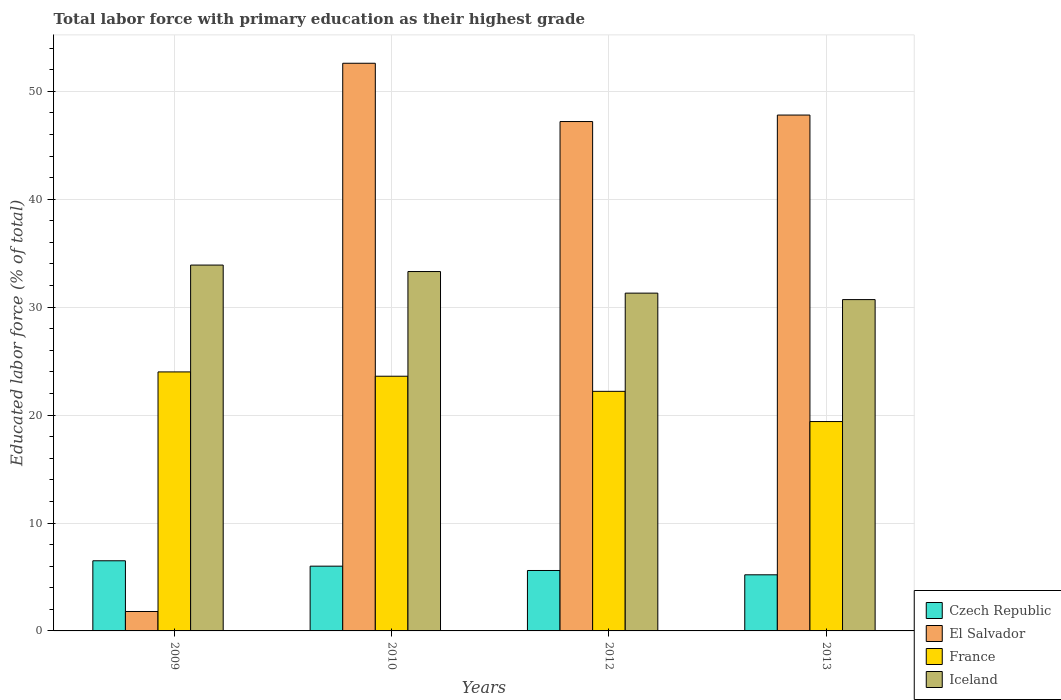Are the number of bars per tick equal to the number of legend labels?
Your response must be concise. Yes. How many bars are there on the 3rd tick from the right?
Your response must be concise. 4. In how many cases, is the number of bars for a given year not equal to the number of legend labels?
Offer a terse response. 0. What is the percentage of total labor force with primary education in France in 2012?
Your answer should be compact. 22.2. Across all years, what is the minimum percentage of total labor force with primary education in El Salvador?
Your answer should be compact. 1.8. In which year was the percentage of total labor force with primary education in Iceland maximum?
Ensure brevity in your answer.  2009. In which year was the percentage of total labor force with primary education in Czech Republic minimum?
Make the answer very short. 2013. What is the total percentage of total labor force with primary education in El Salvador in the graph?
Make the answer very short. 149.4. What is the difference between the percentage of total labor force with primary education in France in 2012 and that in 2013?
Ensure brevity in your answer.  2.8. What is the average percentage of total labor force with primary education in Iceland per year?
Provide a succinct answer. 32.3. In the year 2013, what is the difference between the percentage of total labor force with primary education in El Salvador and percentage of total labor force with primary education in France?
Provide a succinct answer. 28.4. In how many years, is the percentage of total labor force with primary education in El Salvador greater than 10 %?
Your answer should be very brief. 3. What is the ratio of the percentage of total labor force with primary education in Iceland in 2009 to that in 2010?
Offer a very short reply. 1.02. Is the percentage of total labor force with primary education in El Salvador in 2009 less than that in 2013?
Your response must be concise. Yes. Is the difference between the percentage of total labor force with primary education in El Salvador in 2010 and 2013 greater than the difference between the percentage of total labor force with primary education in France in 2010 and 2013?
Make the answer very short. Yes. What is the difference between the highest and the second highest percentage of total labor force with primary education in Iceland?
Your answer should be very brief. 0.6. What is the difference between the highest and the lowest percentage of total labor force with primary education in France?
Provide a succinct answer. 4.6. In how many years, is the percentage of total labor force with primary education in El Salvador greater than the average percentage of total labor force with primary education in El Salvador taken over all years?
Your answer should be very brief. 3. Is it the case that in every year, the sum of the percentage of total labor force with primary education in Czech Republic and percentage of total labor force with primary education in France is greater than the sum of percentage of total labor force with primary education in El Salvador and percentage of total labor force with primary education in Iceland?
Provide a succinct answer. No. What does the 1st bar from the left in 2010 represents?
Your answer should be very brief. Czech Republic. What does the 1st bar from the right in 2012 represents?
Keep it short and to the point. Iceland. How many bars are there?
Keep it short and to the point. 16. How many years are there in the graph?
Your answer should be very brief. 4. Are the values on the major ticks of Y-axis written in scientific E-notation?
Your answer should be very brief. No. Does the graph contain any zero values?
Offer a very short reply. No. Does the graph contain grids?
Provide a succinct answer. Yes. Where does the legend appear in the graph?
Provide a short and direct response. Bottom right. How are the legend labels stacked?
Your answer should be very brief. Vertical. What is the title of the graph?
Keep it short and to the point. Total labor force with primary education as their highest grade. Does "Dominica" appear as one of the legend labels in the graph?
Provide a short and direct response. No. What is the label or title of the X-axis?
Offer a very short reply. Years. What is the label or title of the Y-axis?
Your answer should be very brief. Educated labor force (% of total). What is the Educated labor force (% of total) in El Salvador in 2009?
Ensure brevity in your answer.  1.8. What is the Educated labor force (% of total) in France in 2009?
Offer a very short reply. 24. What is the Educated labor force (% of total) in Iceland in 2009?
Provide a succinct answer. 33.9. What is the Educated labor force (% of total) of Czech Republic in 2010?
Offer a terse response. 6. What is the Educated labor force (% of total) in El Salvador in 2010?
Your answer should be compact. 52.6. What is the Educated labor force (% of total) in France in 2010?
Your answer should be compact. 23.6. What is the Educated labor force (% of total) in Iceland in 2010?
Offer a terse response. 33.3. What is the Educated labor force (% of total) of Czech Republic in 2012?
Make the answer very short. 5.6. What is the Educated labor force (% of total) of El Salvador in 2012?
Offer a terse response. 47.2. What is the Educated labor force (% of total) of France in 2012?
Your response must be concise. 22.2. What is the Educated labor force (% of total) of Iceland in 2012?
Keep it short and to the point. 31.3. What is the Educated labor force (% of total) in Czech Republic in 2013?
Ensure brevity in your answer.  5.2. What is the Educated labor force (% of total) of El Salvador in 2013?
Offer a very short reply. 47.8. What is the Educated labor force (% of total) of France in 2013?
Offer a terse response. 19.4. What is the Educated labor force (% of total) in Iceland in 2013?
Make the answer very short. 30.7. Across all years, what is the maximum Educated labor force (% of total) of Czech Republic?
Your answer should be very brief. 6.5. Across all years, what is the maximum Educated labor force (% of total) of El Salvador?
Provide a succinct answer. 52.6. Across all years, what is the maximum Educated labor force (% of total) in Iceland?
Your response must be concise. 33.9. Across all years, what is the minimum Educated labor force (% of total) in Czech Republic?
Your answer should be compact. 5.2. Across all years, what is the minimum Educated labor force (% of total) of El Salvador?
Your response must be concise. 1.8. Across all years, what is the minimum Educated labor force (% of total) of France?
Provide a succinct answer. 19.4. Across all years, what is the minimum Educated labor force (% of total) in Iceland?
Provide a short and direct response. 30.7. What is the total Educated labor force (% of total) in Czech Republic in the graph?
Offer a very short reply. 23.3. What is the total Educated labor force (% of total) in El Salvador in the graph?
Ensure brevity in your answer.  149.4. What is the total Educated labor force (% of total) of France in the graph?
Your answer should be compact. 89.2. What is the total Educated labor force (% of total) in Iceland in the graph?
Offer a terse response. 129.2. What is the difference between the Educated labor force (% of total) in El Salvador in 2009 and that in 2010?
Your answer should be compact. -50.8. What is the difference between the Educated labor force (% of total) in Czech Republic in 2009 and that in 2012?
Your answer should be compact. 0.9. What is the difference between the Educated labor force (% of total) in El Salvador in 2009 and that in 2012?
Your answer should be compact. -45.4. What is the difference between the Educated labor force (% of total) of France in 2009 and that in 2012?
Provide a succinct answer. 1.8. What is the difference between the Educated labor force (% of total) in Iceland in 2009 and that in 2012?
Your answer should be compact. 2.6. What is the difference between the Educated labor force (% of total) in El Salvador in 2009 and that in 2013?
Offer a terse response. -46. What is the difference between the Educated labor force (% of total) in Iceland in 2009 and that in 2013?
Offer a very short reply. 3.2. What is the difference between the Educated labor force (% of total) of Iceland in 2010 and that in 2012?
Your answer should be compact. 2. What is the difference between the Educated labor force (% of total) of Czech Republic in 2010 and that in 2013?
Ensure brevity in your answer.  0.8. What is the difference between the Educated labor force (% of total) in Iceland in 2010 and that in 2013?
Provide a short and direct response. 2.6. What is the difference between the Educated labor force (% of total) of Iceland in 2012 and that in 2013?
Offer a terse response. 0.6. What is the difference between the Educated labor force (% of total) in Czech Republic in 2009 and the Educated labor force (% of total) in El Salvador in 2010?
Make the answer very short. -46.1. What is the difference between the Educated labor force (% of total) in Czech Republic in 2009 and the Educated labor force (% of total) in France in 2010?
Your answer should be very brief. -17.1. What is the difference between the Educated labor force (% of total) of Czech Republic in 2009 and the Educated labor force (% of total) of Iceland in 2010?
Provide a succinct answer. -26.8. What is the difference between the Educated labor force (% of total) of El Salvador in 2009 and the Educated labor force (% of total) of France in 2010?
Your response must be concise. -21.8. What is the difference between the Educated labor force (% of total) of El Salvador in 2009 and the Educated labor force (% of total) of Iceland in 2010?
Your response must be concise. -31.5. What is the difference between the Educated labor force (% of total) of Czech Republic in 2009 and the Educated labor force (% of total) of El Salvador in 2012?
Your response must be concise. -40.7. What is the difference between the Educated labor force (% of total) of Czech Republic in 2009 and the Educated labor force (% of total) of France in 2012?
Make the answer very short. -15.7. What is the difference between the Educated labor force (% of total) in Czech Republic in 2009 and the Educated labor force (% of total) in Iceland in 2012?
Provide a short and direct response. -24.8. What is the difference between the Educated labor force (% of total) in El Salvador in 2009 and the Educated labor force (% of total) in France in 2012?
Provide a short and direct response. -20.4. What is the difference between the Educated labor force (% of total) of El Salvador in 2009 and the Educated labor force (% of total) of Iceland in 2012?
Your answer should be very brief. -29.5. What is the difference between the Educated labor force (% of total) of France in 2009 and the Educated labor force (% of total) of Iceland in 2012?
Ensure brevity in your answer.  -7.3. What is the difference between the Educated labor force (% of total) in Czech Republic in 2009 and the Educated labor force (% of total) in El Salvador in 2013?
Provide a succinct answer. -41.3. What is the difference between the Educated labor force (% of total) in Czech Republic in 2009 and the Educated labor force (% of total) in Iceland in 2013?
Ensure brevity in your answer.  -24.2. What is the difference between the Educated labor force (% of total) of El Salvador in 2009 and the Educated labor force (% of total) of France in 2013?
Make the answer very short. -17.6. What is the difference between the Educated labor force (% of total) in El Salvador in 2009 and the Educated labor force (% of total) in Iceland in 2013?
Your answer should be compact. -28.9. What is the difference between the Educated labor force (% of total) in Czech Republic in 2010 and the Educated labor force (% of total) in El Salvador in 2012?
Give a very brief answer. -41.2. What is the difference between the Educated labor force (% of total) in Czech Republic in 2010 and the Educated labor force (% of total) in France in 2012?
Your answer should be very brief. -16.2. What is the difference between the Educated labor force (% of total) of Czech Republic in 2010 and the Educated labor force (% of total) of Iceland in 2012?
Give a very brief answer. -25.3. What is the difference between the Educated labor force (% of total) in El Salvador in 2010 and the Educated labor force (% of total) in France in 2012?
Your response must be concise. 30.4. What is the difference between the Educated labor force (% of total) in El Salvador in 2010 and the Educated labor force (% of total) in Iceland in 2012?
Your response must be concise. 21.3. What is the difference between the Educated labor force (% of total) in France in 2010 and the Educated labor force (% of total) in Iceland in 2012?
Keep it short and to the point. -7.7. What is the difference between the Educated labor force (% of total) in Czech Republic in 2010 and the Educated labor force (% of total) in El Salvador in 2013?
Your answer should be very brief. -41.8. What is the difference between the Educated labor force (% of total) in Czech Republic in 2010 and the Educated labor force (% of total) in France in 2013?
Your answer should be very brief. -13.4. What is the difference between the Educated labor force (% of total) in Czech Republic in 2010 and the Educated labor force (% of total) in Iceland in 2013?
Make the answer very short. -24.7. What is the difference between the Educated labor force (% of total) of El Salvador in 2010 and the Educated labor force (% of total) of France in 2013?
Your answer should be compact. 33.2. What is the difference between the Educated labor force (% of total) in El Salvador in 2010 and the Educated labor force (% of total) in Iceland in 2013?
Make the answer very short. 21.9. What is the difference between the Educated labor force (% of total) of France in 2010 and the Educated labor force (% of total) of Iceland in 2013?
Offer a terse response. -7.1. What is the difference between the Educated labor force (% of total) in Czech Republic in 2012 and the Educated labor force (% of total) in El Salvador in 2013?
Ensure brevity in your answer.  -42.2. What is the difference between the Educated labor force (% of total) of Czech Republic in 2012 and the Educated labor force (% of total) of France in 2013?
Keep it short and to the point. -13.8. What is the difference between the Educated labor force (% of total) in Czech Republic in 2012 and the Educated labor force (% of total) in Iceland in 2013?
Offer a very short reply. -25.1. What is the difference between the Educated labor force (% of total) of El Salvador in 2012 and the Educated labor force (% of total) of France in 2013?
Keep it short and to the point. 27.8. What is the average Educated labor force (% of total) in Czech Republic per year?
Offer a very short reply. 5.83. What is the average Educated labor force (% of total) of El Salvador per year?
Your response must be concise. 37.35. What is the average Educated labor force (% of total) of France per year?
Give a very brief answer. 22.3. What is the average Educated labor force (% of total) of Iceland per year?
Provide a succinct answer. 32.3. In the year 2009, what is the difference between the Educated labor force (% of total) of Czech Republic and Educated labor force (% of total) of El Salvador?
Your answer should be very brief. 4.7. In the year 2009, what is the difference between the Educated labor force (% of total) of Czech Republic and Educated labor force (% of total) of France?
Ensure brevity in your answer.  -17.5. In the year 2009, what is the difference between the Educated labor force (% of total) in Czech Republic and Educated labor force (% of total) in Iceland?
Keep it short and to the point. -27.4. In the year 2009, what is the difference between the Educated labor force (% of total) of El Salvador and Educated labor force (% of total) of France?
Give a very brief answer. -22.2. In the year 2009, what is the difference between the Educated labor force (% of total) in El Salvador and Educated labor force (% of total) in Iceland?
Offer a terse response. -32.1. In the year 2009, what is the difference between the Educated labor force (% of total) in France and Educated labor force (% of total) in Iceland?
Give a very brief answer. -9.9. In the year 2010, what is the difference between the Educated labor force (% of total) of Czech Republic and Educated labor force (% of total) of El Salvador?
Ensure brevity in your answer.  -46.6. In the year 2010, what is the difference between the Educated labor force (% of total) in Czech Republic and Educated labor force (% of total) in France?
Your answer should be compact. -17.6. In the year 2010, what is the difference between the Educated labor force (% of total) of Czech Republic and Educated labor force (% of total) of Iceland?
Offer a very short reply. -27.3. In the year 2010, what is the difference between the Educated labor force (% of total) of El Salvador and Educated labor force (% of total) of France?
Give a very brief answer. 29. In the year 2010, what is the difference between the Educated labor force (% of total) of El Salvador and Educated labor force (% of total) of Iceland?
Give a very brief answer. 19.3. In the year 2010, what is the difference between the Educated labor force (% of total) in France and Educated labor force (% of total) in Iceland?
Make the answer very short. -9.7. In the year 2012, what is the difference between the Educated labor force (% of total) of Czech Republic and Educated labor force (% of total) of El Salvador?
Your response must be concise. -41.6. In the year 2012, what is the difference between the Educated labor force (% of total) of Czech Republic and Educated labor force (% of total) of France?
Keep it short and to the point. -16.6. In the year 2012, what is the difference between the Educated labor force (% of total) of Czech Republic and Educated labor force (% of total) of Iceland?
Your answer should be very brief. -25.7. In the year 2012, what is the difference between the Educated labor force (% of total) of El Salvador and Educated labor force (% of total) of France?
Offer a terse response. 25. In the year 2012, what is the difference between the Educated labor force (% of total) of El Salvador and Educated labor force (% of total) of Iceland?
Your response must be concise. 15.9. In the year 2012, what is the difference between the Educated labor force (% of total) in France and Educated labor force (% of total) in Iceland?
Make the answer very short. -9.1. In the year 2013, what is the difference between the Educated labor force (% of total) in Czech Republic and Educated labor force (% of total) in El Salvador?
Make the answer very short. -42.6. In the year 2013, what is the difference between the Educated labor force (% of total) in Czech Republic and Educated labor force (% of total) in Iceland?
Offer a very short reply. -25.5. In the year 2013, what is the difference between the Educated labor force (% of total) of El Salvador and Educated labor force (% of total) of France?
Provide a short and direct response. 28.4. In the year 2013, what is the difference between the Educated labor force (% of total) of El Salvador and Educated labor force (% of total) of Iceland?
Ensure brevity in your answer.  17.1. In the year 2013, what is the difference between the Educated labor force (% of total) of France and Educated labor force (% of total) of Iceland?
Give a very brief answer. -11.3. What is the ratio of the Educated labor force (% of total) of El Salvador in 2009 to that in 2010?
Give a very brief answer. 0.03. What is the ratio of the Educated labor force (% of total) in France in 2009 to that in 2010?
Offer a terse response. 1.02. What is the ratio of the Educated labor force (% of total) in Iceland in 2009 to that in 2010?
Offer a very short reply. 1.02. What is the ratio of the Educated labor force (% of total) of Czech Republic in 2009 to that in 2012?
Make the answer very short. 1.16. What is the ratio of the Educated labor force (% of total) of El Salvador in 2009 to that in 2012?
Your answer should be compact. 0.04. What is the ratio of the Educated labor force (% of total) in France in 2009 to that in 2012?
Ensure brevity in your answer.  1.08. What is the ratio of the Educated labor force (% of total) of Iceland in 2009 to that in 2012?
Provide a succinct answer. 1.08. What is the ratio of the Educated labor force (% of total) in El Salvador in 2009 to that in 2013?
Offer a very short reply. 0.04. What is the ratio of the Educated labor force (% of total) in France in 2009 to that in 2013?
Your answer should be compact. 1.24. What is the ratio of the Educated labor force (% of total) in Iceland in 2009 to that in 2013?
Keep it short and to the point. 1.1. What is the ratio of the Educated labor force (% of total) in Czech Republic in 2010 to that in 2012?
Make the answer very short. 1.07. What is the ratio of the Educated labor force (% of total) in El Salvador in 2010 to that in 2012?
Give a very brief answer. 1.11. What is the ratio of the Educated labor force (% of total) in France in 2010 to that in 2012?
Your answer should be compact. 1.06. What is the ratio of the Educated labor force (% of total) in Iceland in 2010 to that in 2012?
Your answer should be very brief. 1.06. What is the ratio of the Educated labor force (% of total) in Czech Republic in 2010 to that in 2013?
Keep it short and to the point. 1.15. What is the ratio of the Educated labor force (% of total) in El Salvador in 2010 to that in 2013?
Offer a very short reply. 1.1. What is the ratio of the Educated labor force (% of total) in France in 2010 to that in 2013?
Your answer should be compact. 1.22. What is the ratio of the Educated labor force (% of total) in Iceland in 2010 to that in 2013?
Provide a short and direct response. 1.08. What is the ratio of the Educated labor force (% of total) in El Salvador in 2012 to that in 2013?
Provide a short and direct response. 0.99. What is the ratio of the Educated labor force (% of total) of France in 2012 to that in 2013?
Ensure brevity in your answer.  1.14. What is the ratio of the Educated labor force (% of total) in Iceland in 2012 to that in 2013?
Offer a very short reply. 1.02. What is the difference between the highest and the second highest Educated labor force (% of total) of France?
Your response must be concise. 0.4. What is the difference between the highest and the second highest Educated labor force (% of total) of Iceland?
Give a very brief answer. 0.6. What is the difference between the highest and the lowest Educated labor force (% of total) in Czech Republic?
Your answer should be very brief. 1.3. What is the difference between the highest and the lowest Educated labor force (% of total) in El Salvador?
Your response must be concise. 50.8. What is the difference between the highest and the lowest Educated labor force (% of total) in France?
Your answer should be compact. 4.6. What is the difference between the highest and the lowest Educated labor force (% of total) of Iceland?
Make the answer very short. 3.2. 